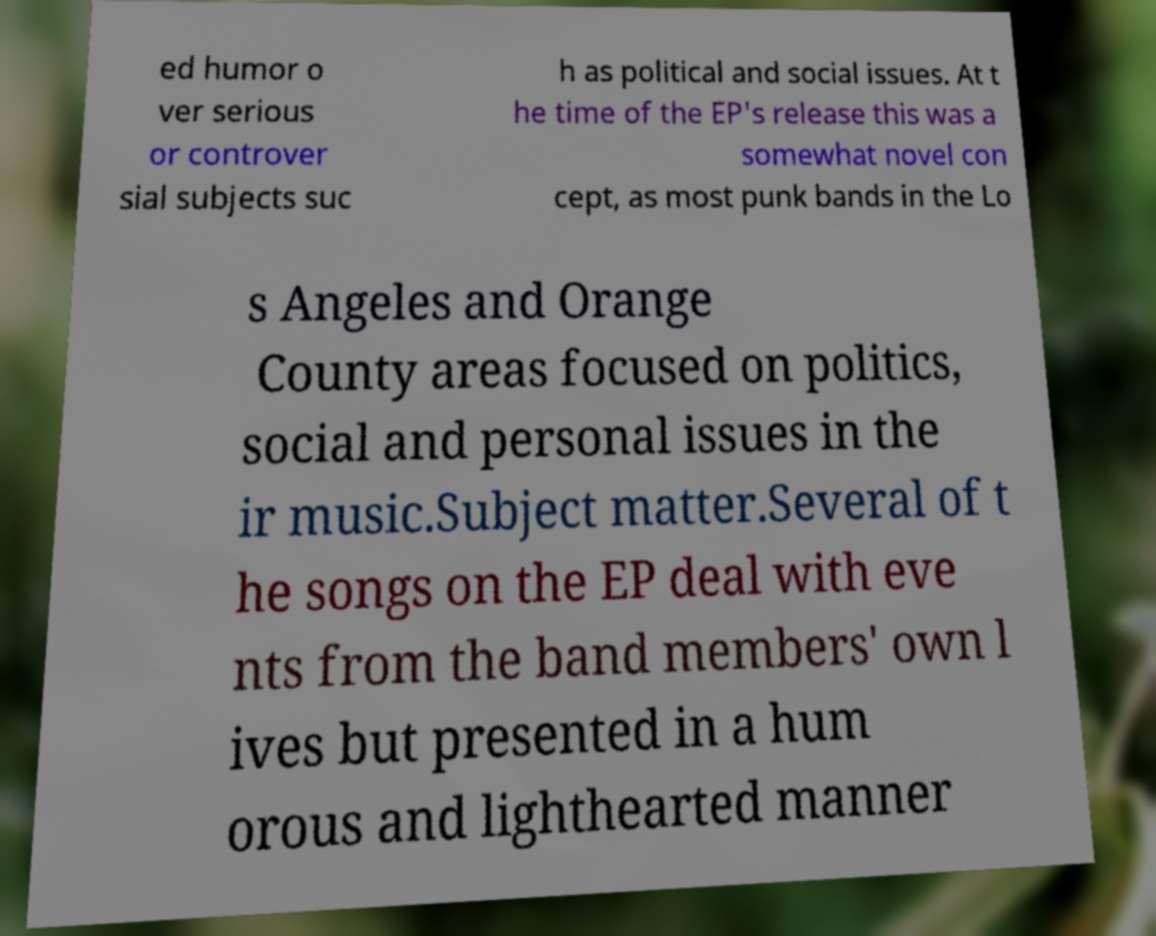Could you extract and type out the text from this image? ed humor o ver serious or controver sial subjects suc h as political and social issues. At t he time of the EP's release this was a somewhat novel con cept, as most punk bands in the Lo s Angeles and Orange County areas focused on politics, social and personal issues in the ir music.Subject matter.Several of t he songs on the EP deal with eve nts from the band members' own l ives but presented in a hum orous and lighthearted manner 